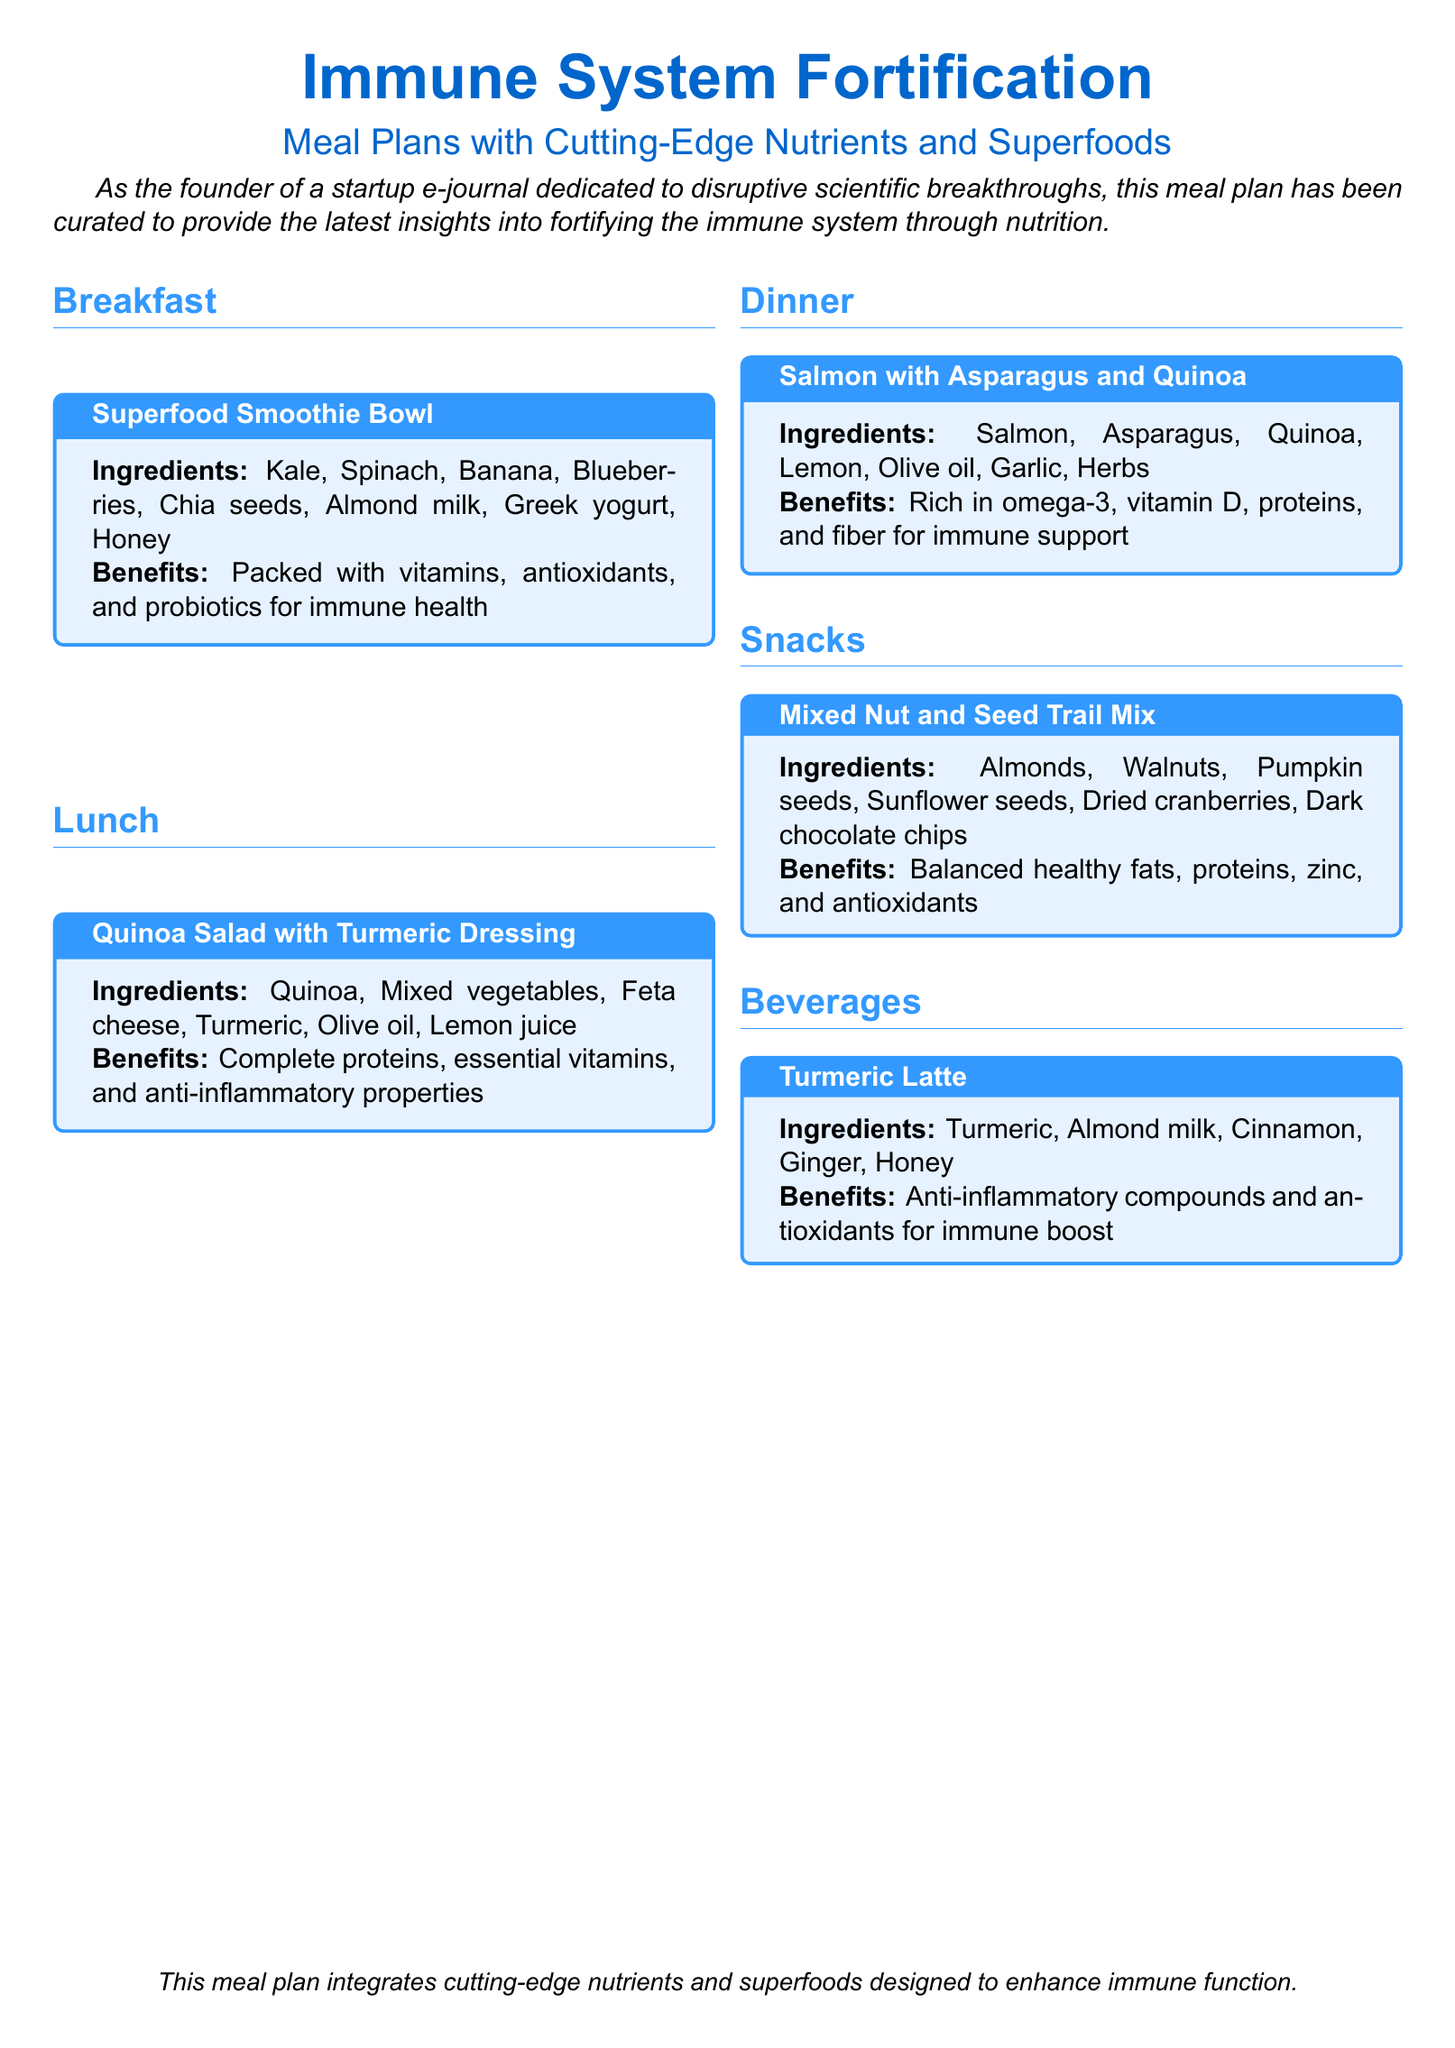What is the title of the document? The title of the document is presented prominently at the top.
Answer: Immune System Fortification What are the key ingredients in the Superfood Smoothie Bowl? The key ingredients are listed in the meal box for breakfast.
Answer: Kale, Spinach, Banana, Blueberries, Chia seeds, Almond milk, Greek yogurt, Honey What is the main benefit of the Quinoa Salad with Turmeric Dressing? The benefits are summarized in the meal box for lunch, focusing on its nutritional value.
Answer: Complete proteins, essential vitamins, and anti-inflammatory properties How many meals are included in the meal plan? The number of meal sections indicates the total meals present.
Answer: Five What type of beverage is recommended for immune boosting? The type of beverage is mentioned in the beverages section.
Answer: Turmeric Latte What are the main ingredients of the mixed nut and seed trail mix? The main ingredients are listed in the snacks section.
Answer: Almonds, Walnuts, Pumpkin seeds, Sunflower seeds, Dried cranberries, Dark chocolate chips What nutrient is notably present in the Salmon with Asparagus and Quinoa meal? The document emphasizes specific nutrients in the dinner meal box.
Answer: Omega-3 What color is used for the section titles? The color of the titles is defined in the document settings.
Answer: RGB(51,153,255) What is the health focus of this meal plan? The overall theme of the meal plan is articulated in the introductory text.
Answer: Immune system fortification 